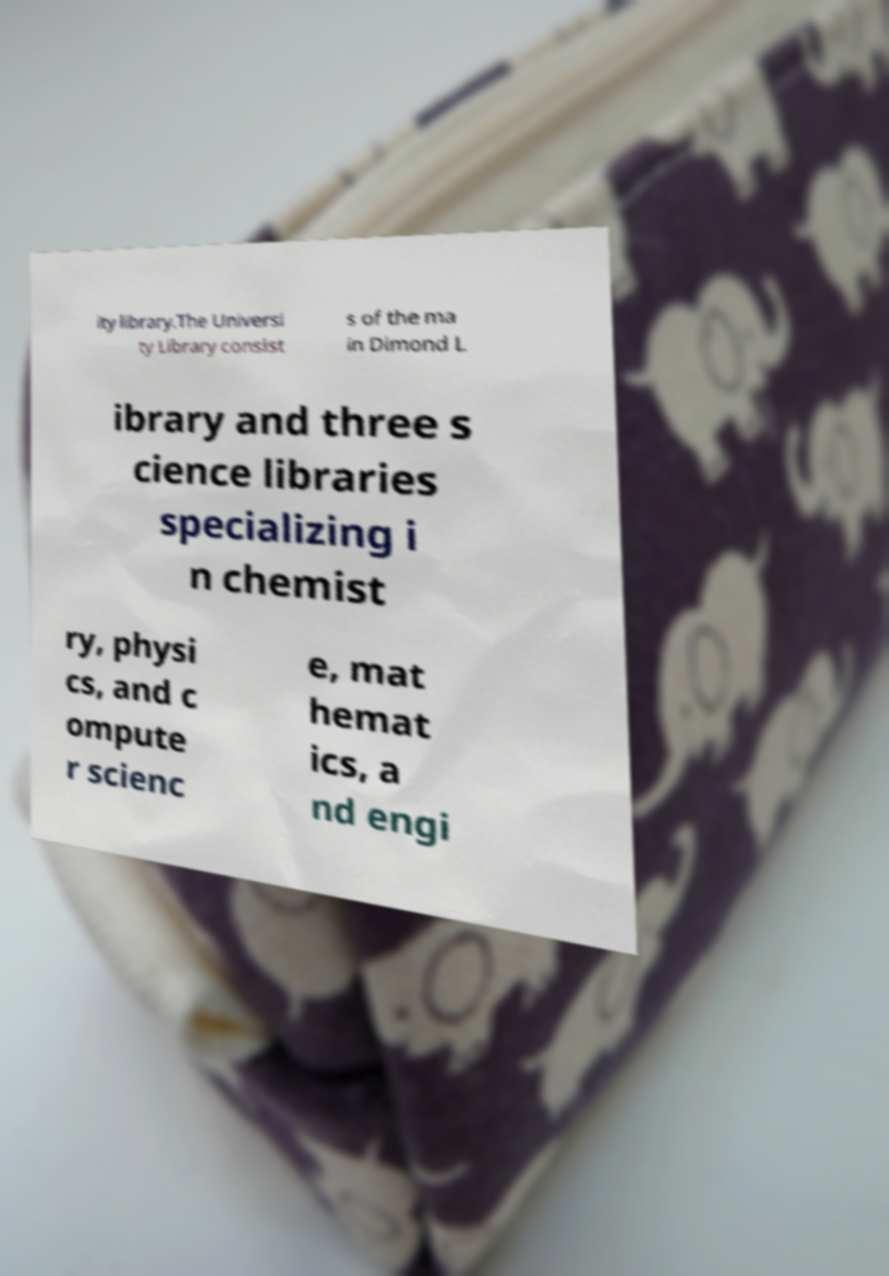Can you read and provide the text displayed in the image?This photo seems to have some interesting text. Can you extract and type it out for me? ity library.The Universi ty Library consist s of the ma in Dimond L ibrary and three s cience libraries specializing i n chemist ry, physi cs, and c ompute r scienc e, mat hemat ics, a nd engi 